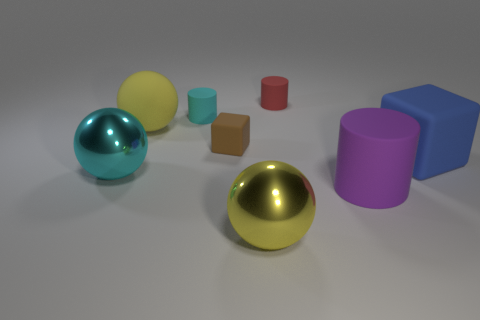Is the number of cyan cylinders that are in front of the yellow rubber ball greater than the number of large purple cylinders that are on the left side of the big matte cylinder?
Offer a very short reply. No. There is a large object that is in front of the big purple matte object; how many large blue things are on the left side of it?
Ensure brevity in your answer.  0. There is a cyan object that is behind the tiny brown object; is its shape the same as the brown thing?
Your answer should be very brief. No. There is a red thing that is the same shape as the purple rubber thing; what is its material?
Provide a succinct answer. Rubber. What number of spheres are the same size as the red cylinder?
Offer a very short reply. 0. There is a small rubber object that is on the left side of the yellow shiny ball and behind the small matte cube; what color is it?
Give a very brief answer. Cyan. Are there fewer large cyan objects than gray metal balls?
Provide a succinct answer. No. Do the small rubber cube and the metallic ball to the right of the big cyan metal ball have the same color?
Provide a succinct answer. No. Are there the same number of yellow rubber spheres in front of the cyan metallic sphere and large blue rubber things that are behind the matte sphere?
Make the answer very short. Yes. How many purple matte things have the same shape as the large cyan metal thing?
Provide a short and direct response. 0. 